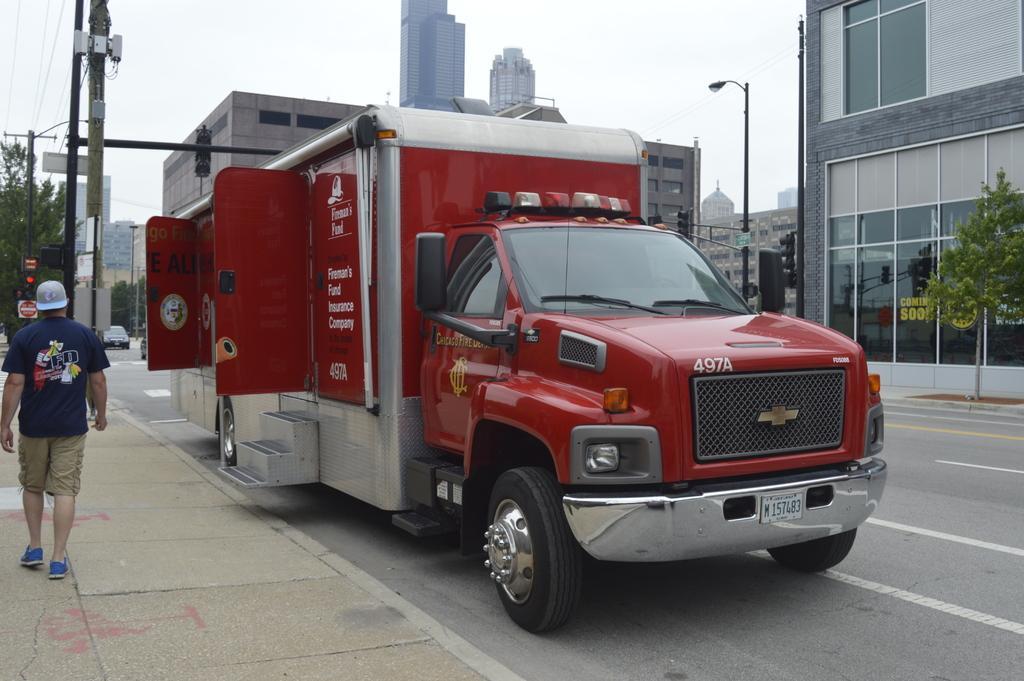In one or two sentences, can you explain what this image depicts? In this image we can see a person. There are many buildings in the image. There are few electrical poles and cables at the left side of the image. There are few street lights at the right side of the image. There are few vehicles in the image. We can see the sky in the image. 